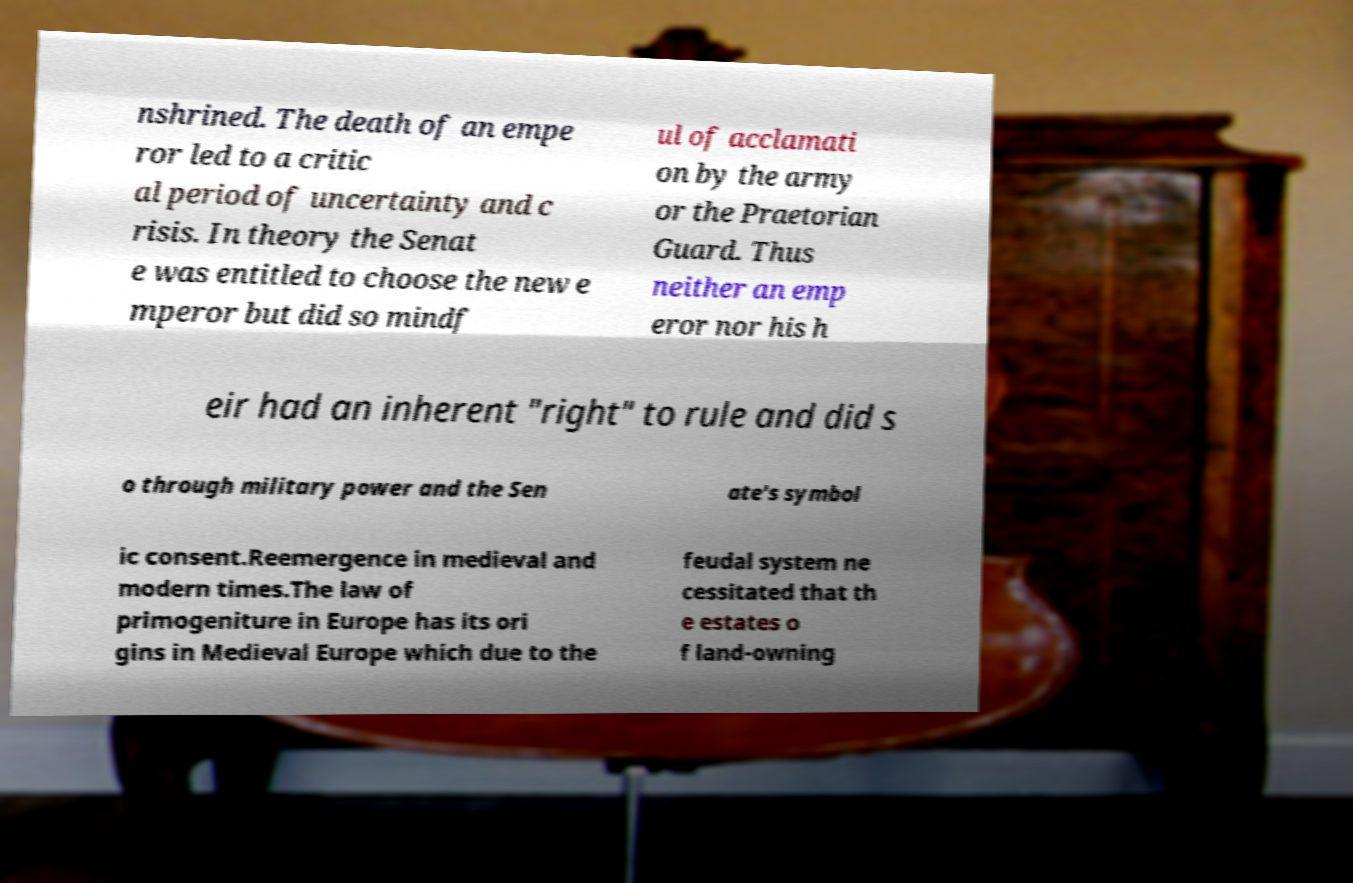For documentation purposes, I need the text within this image transcribed. Could you provide that? nshrined. The death of an empe ror led to a critic al period of uncertainty and c risis. In theory the Senat e was entitled to choose the new e mperor but did so mindf ul of acclamati on by the army or the Praetorian Guard. Thus neither an emp eror nor his h eir had an inherent "right" to rule and did s o through military power and the Sen ate's symbol ic consent.Reemergence in medieval and modern times.The law of primogeniture in Europe has its ori gins in Medieval Europe which due to the feudal system ne cessitated that th e estates o f land-owning 